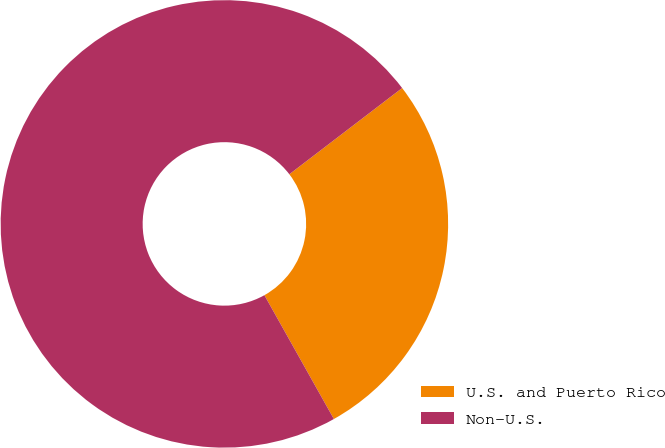Convert chart to OTSL. <chart><loc_0><loc_0><loc_500><loc_500><pie_chart><fcel>U.S. and Puerto Rico<fcel>Non-U.S.<nl><fcel>27.25%<fcel>72.75%<nl></chart> 